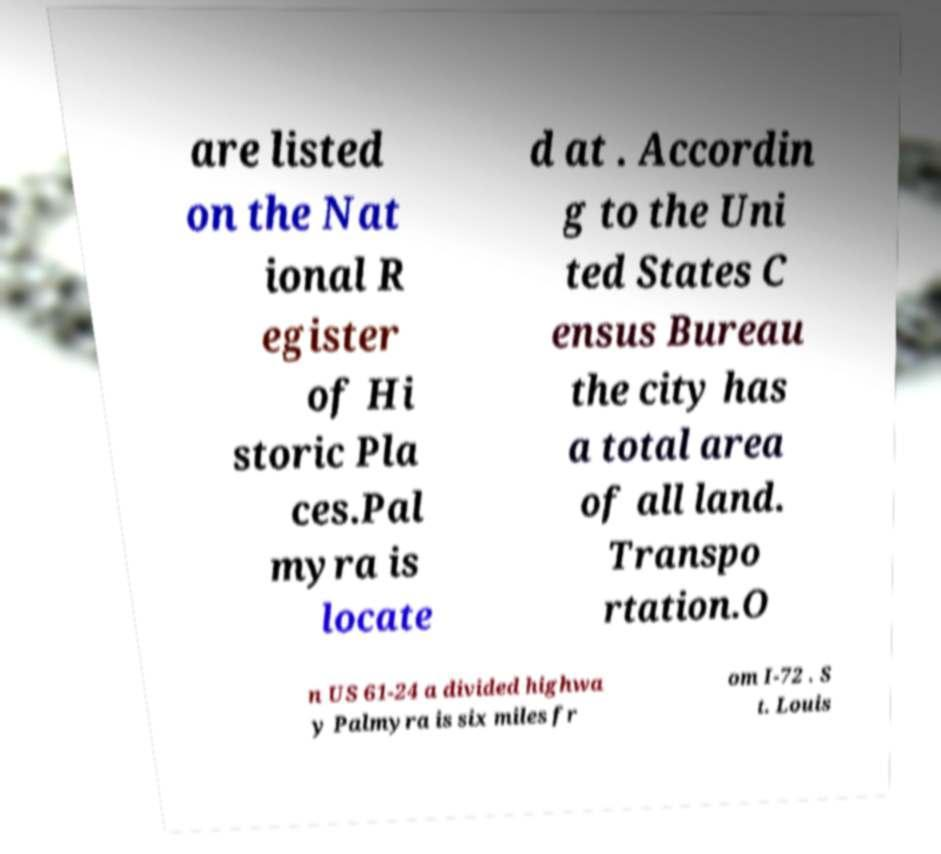For documentation purposes, I need the text within this image transcribed. Could you provide that? are listed on the Nat ional R egister of Hi storic Pla ces.Pal myra is locate d at . Accordin g to the Uni ted States C ensus Bureau the city has a total area of all land. Transpo rtation.O n US 61-24 a divided highwa y Palmyra is six miles fr om I-72 . S t. Louis 